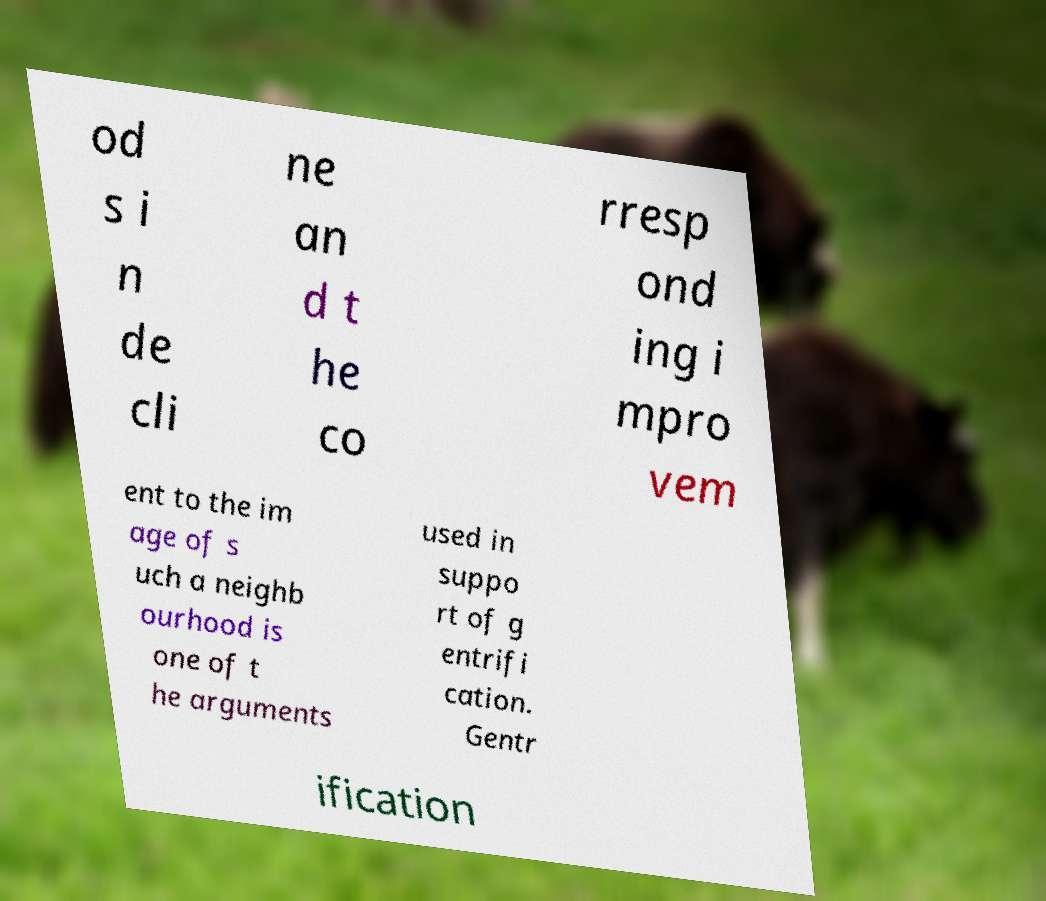What messages or text are displayed in this image? I need them in a readable, typed format. od s i n de cli ne an d t he co rresp ond ing i mpro vem ent to the im age of s uch a neighb ourhood is one of t he arguments used in suppo rt of g entrifi cation. Gentr ification 